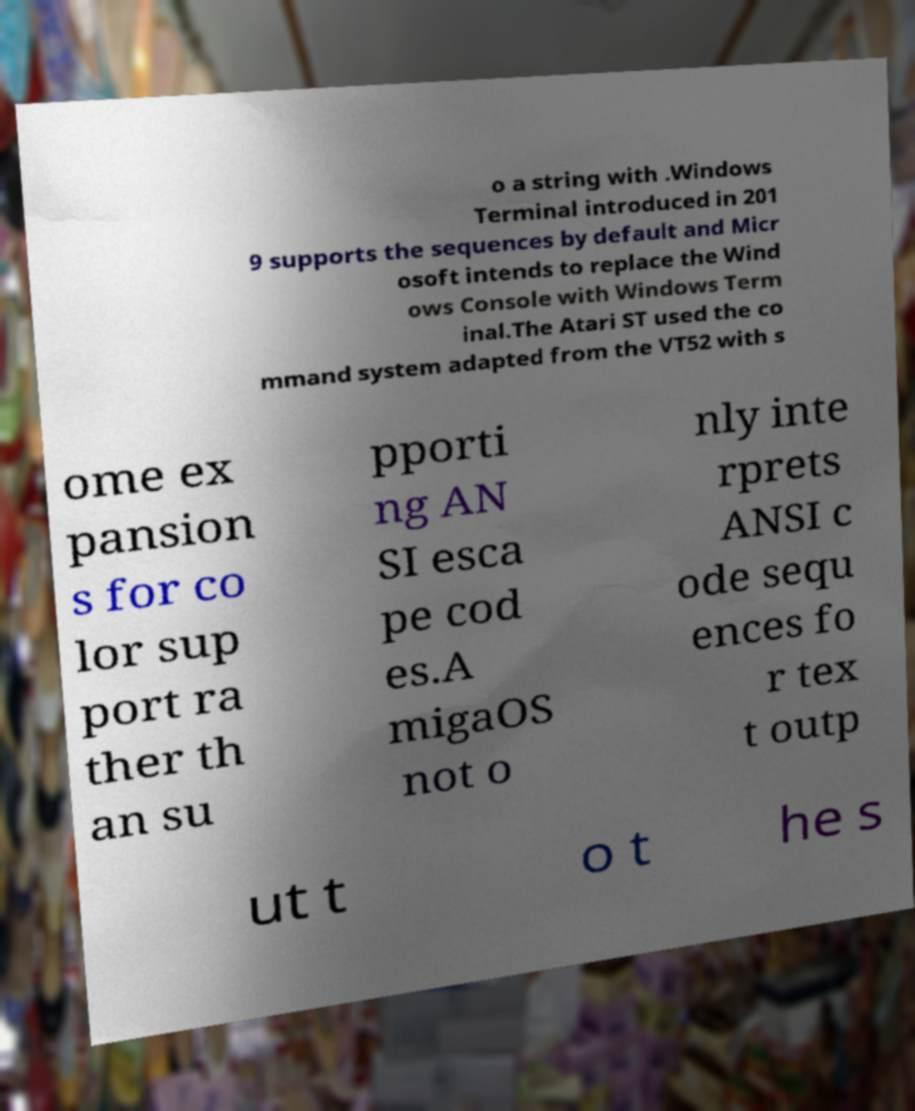Could you assist in decoding the text presented in this image and type it out clearly? o a string with .Windows Terminal introduced in 201 9 supports the sequences by default and Micr osoft intends to replace the Wind ows Console with Windows Term inal.The Atari ST used the co mmand system adapted from the VT52 with s ome ex pansion s for co lor sup port ra ther th an su pporti ng AN SI esca pe cod es.A migaOS not o nly inte rprets ANSI c ode sequ ences fo r tex t outp ut t o t he s 